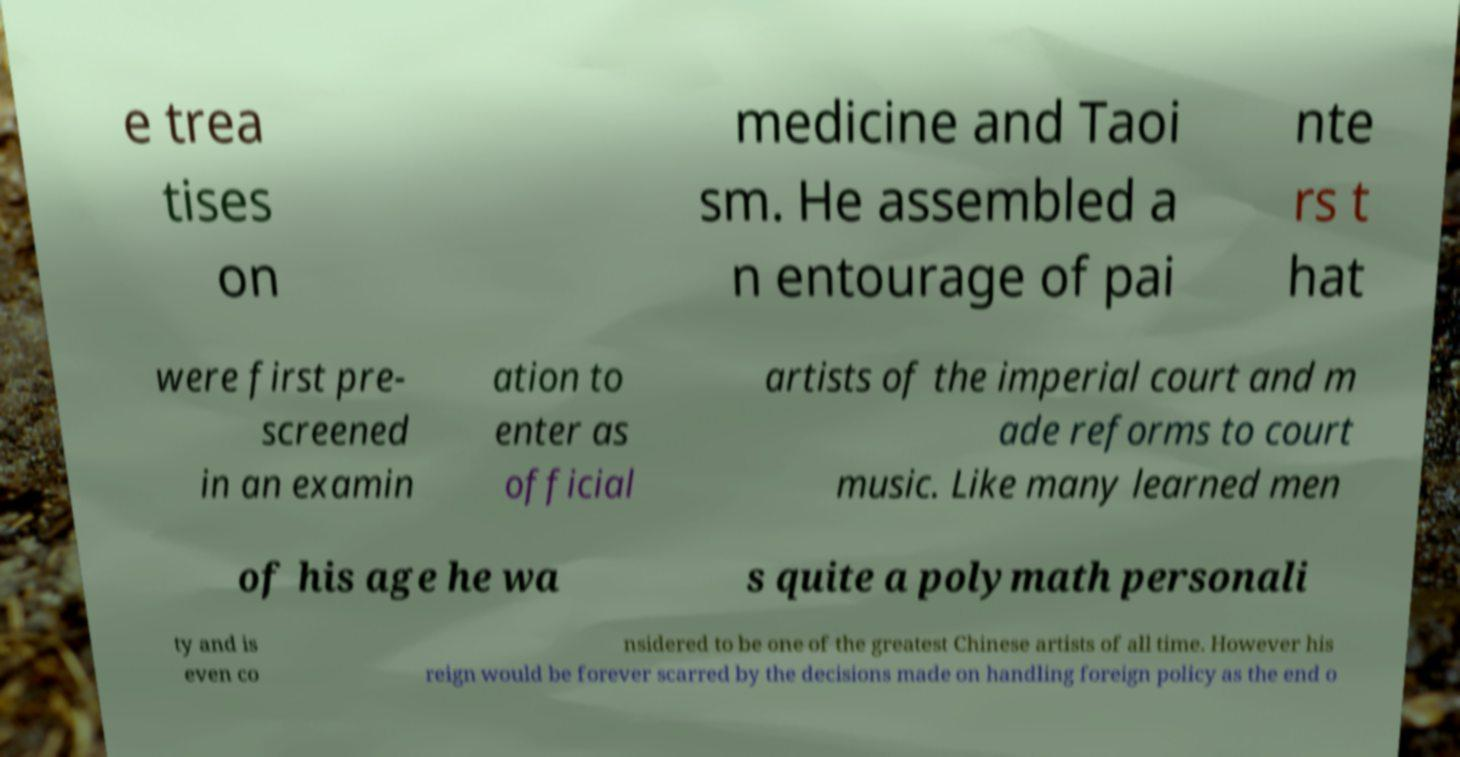Can you accurately transcribe the text from the provided image for me? e trea tises on medicine and Taoi sm. He assembled a n entourage of pai nte rs t hat were first pre- screened in an examin ation to enter as official artists of the imperial court and m ade reforms to court music. Like many learned men of his age he wa s quite a polymath personali ty and is even co nsidered to be one of the greatest Chinese artists of all time. However his reign would be forever scarred by the decisions made on handling foreign policy as the end o 